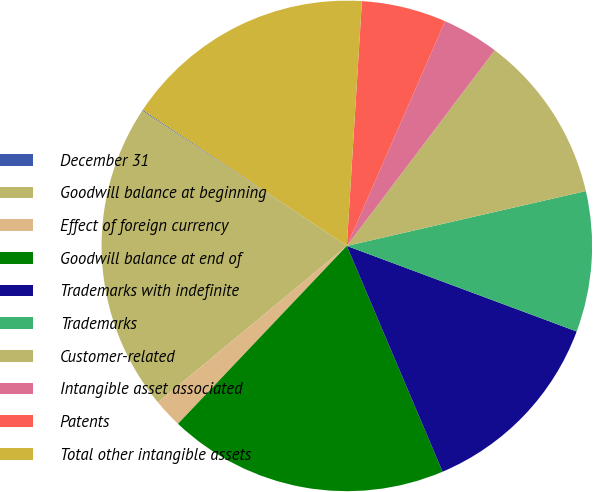<chart> <loc_0><loc_0><loc_500><loc_500><pie_chart><fcel>December 31<fcel>Goodwill balance at beginning<fcel>Effect of foreign currency<fcel>Goodwill balance at end of<fcel>Trademarks with indefinite<fcel>Trademarks<fcel>Customer-related<fcel>Intangible asset associated<fcel>Patents<fcel>Total other intangible assets<nl><fcel>0.06%<fcel>20.3%<fcel>1.9%<fcel>18.46%<fcel>12.94%<fcel>9.26%<fcel>11.1%<fcel>3.74%<fcel>5.58%<fcel>16.62%<nl></chart> 